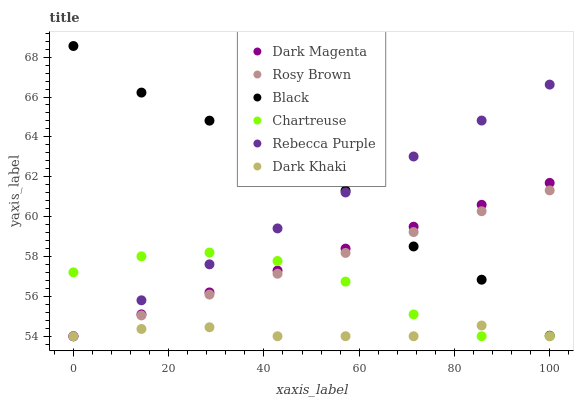Does Dark Khaki have the minimum area under the curve?
Answer yes or no. Yes. Does Black have the maximum area under the curve?
Answer yes or no. Yes. Does Rosy Brown have the minimum area under the curve?
Answer yes or no. No. Does Rosy Brown have the maximum area under the curve?
Answer yes or no. No. Is Rosy Brown the smoothest?
Answer yes or no. Yes. Is Black the roughest?
Answer yes or no. Yes. Is Dark Khaki the smoothest?
Answer yes or no. No. Is Dark Khaki the roughest?
Answer yes or no. No. Does Dark Magenta have the lowest value?
Answer yes or no. Yes. Does Black have the lowest value?
Answer yes or no. No. Does Black have the highest value?
Answer yes or no. Yes. Does Rosy Brown have the highest value?
Answer yes or no. No. Is Chartreuse less than Black?
Answer yes or no. Yes. Is Black greater than Chartreuse?
Answer yes or no. Yes. Does Rebecca Purple intersect Dark Magenta?
Answer yes or no. Yes. Is Rebecca Purple less than Dark Magenta?
Answer yes or no. No. Is Rebecca Purple greater than Dark Magenta?
Answer yes or no. No. Does Chartreuse intersect Black?
Answer yes or no. No. 